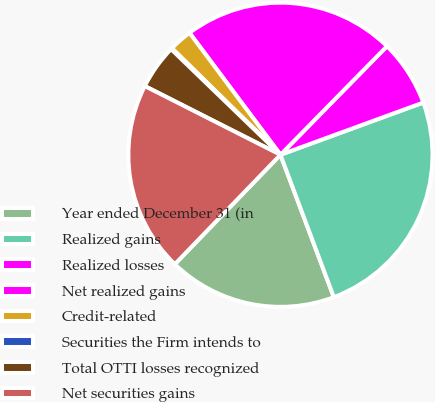Convert chart to OTSL. <chart><loc_0><loc_0><loc_500><loc_500><pie_chart><fcel>Year ended December 31 (in<fcel>Realized gains<fcel>Realized losses<fcel>Net realized gains<fcel>Credit-related<fcel>Securities the Firm intends to<fcel>Total OTTI losses recognized<fcel>Net securities gains<nl><fcel>17.93%<fcel>24.87%<fcel>7.07%<fcel>22.55%<fcel>2.45%<fcel>0.13%<fcel>4.76%<fcel>20.24%<nl></chart> 